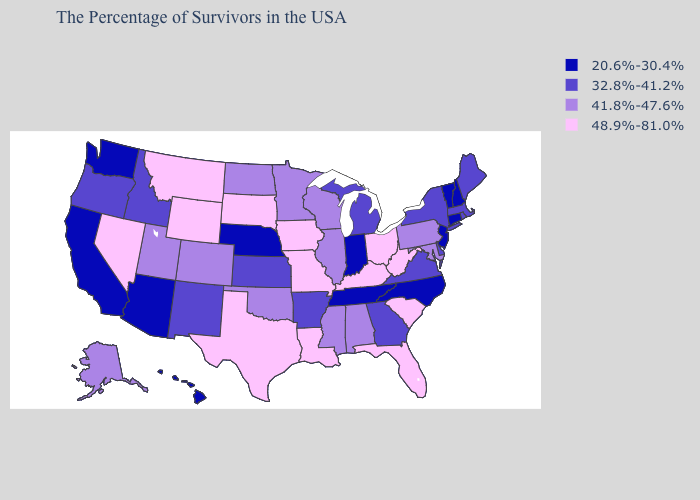Among the states that border Kansas , which have the highest value?
Write a very short answer. Missouri. What is the lowest value in states that border Utah?
Short answer required. 20.6%-30.4%. Among the states that border Texas , which have the highest value?
Answer briefly. Louisiana. Name the states that have a value in the range 32.8%-41.2%?
Short answer required. Maine, Massachusetts, Rhode Island, New York, Delaware, Virginia, Georgia, Michigan, Arkansas, Kansas, New Mexico, Idaho, Oregon. What is the highest value in the USA?
Short answer required. 48.9%-81.0%. Does the first symbol in the legend represent the smallest category?
Keep it brief. Yes. Among the states that border Nevada , which have the highest value?
Answer briefly. Utah. What is the value of Nevada?
Keep it brief. 48.9%-81.0%. Name the states that have a value in the range 48.9%-81.0%?
Keep it brief. South Carolina, West Virginia, Ohio, Florida, Kentucky, Louisiana, Missouri, Iowa, Texas, South Dakota, Wyoming, Montana, Nevada. Among the states that border Rhode Island , which have the lowest value?
Give a very brief answer. Connecticut. Is the legend a continuous bar?
Be succinct. No. What is the value of Texas?
Be succinct. 48.9%-81.0%. What is the lowest value in the MidWest?
Quick response, please. 20.6%-30.4%. Which states have the highest value in the USA?
Answer briefly. South Carolina, West Virginia, Ohio, Florida, Kentucky, Louisiana, Missouri, Iowa, Texas, South Dakota, Wyoming, Montana, Nevada. Name the states that have a value in the range 41.8%-47.6%?
Quick response, please. Maryland, Pennsylvania, Alabama, Wisconsin, Illinois, Mississippi, Minnesota, Oklahoma, North Dakota, Colorado, Utah, Alaska. 